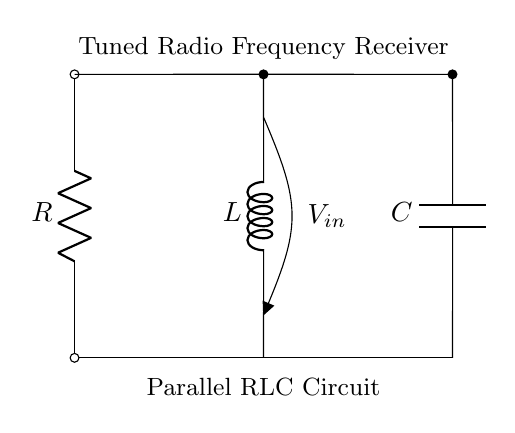What components are present in the circuit? The circuit consists of a resistor, an inductor, and a capacitor connected in parallel. These components are essential for the tuning functionality of a radio frequency receiver.
Answer: Resistor, Inductor, Capacitor What is the role of the inductor in this circuit? The inductor plays a key role in filtering signals. It stores energy in a magnetic field and can resonate with the capacitor at a specific frequency, allowing for selective frequency tuning.
Answer: Filtering signals What type of circuit is represented here? This is a parallel RLC circuit, which is commonly used in tuned radio frequency receivers due to its ability to select a desired frequency and reject others.
Answer: Parallel RLC circuit What happens to the voltage across components in this configuration? In a parallel circuit, the voltage across all components is the same; thus, they all experience the same input voltage, which is critical for the operation of the receiver.
Answer: Same voltage What is the significance of tuning in this circuit? Tuning allows the receiver to filter and amplify a specific radio frequency signal while disregarding others, which is vital for clear reception of transmitted signals.
Answer: Signal filtering How does the resonant frequency depend on the inductor and capacitor? The resonant frequency is determined by the values of the inductor and capacitor and is calculated using the formula 1 over the square root of the product of inductance and capacitance, indicating a relationship that allows specific frequency selection.
Answer: Inductor and capacitor values 